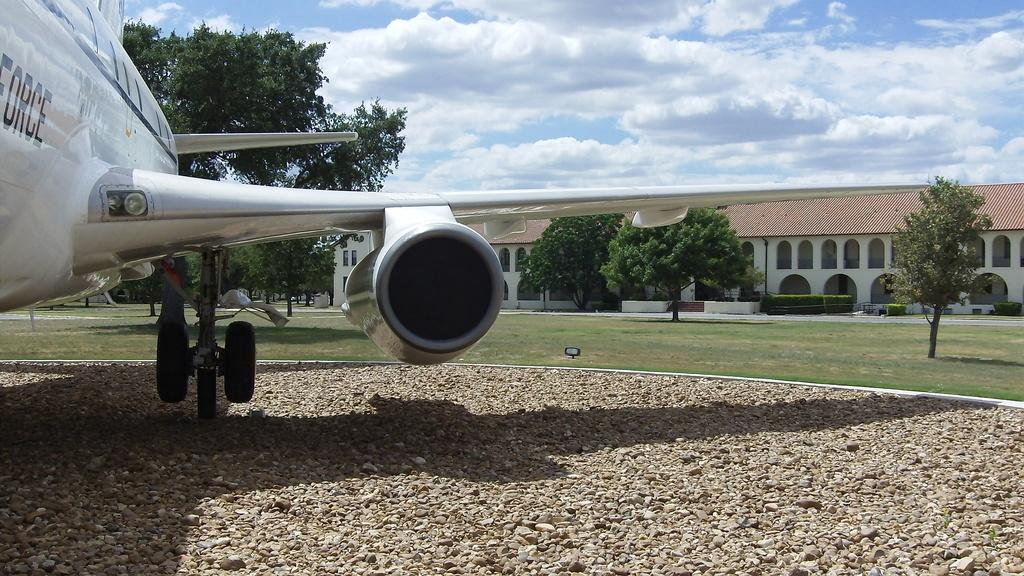Provide a one-sentence caption for the provided image. A white plane with Force written on it. 